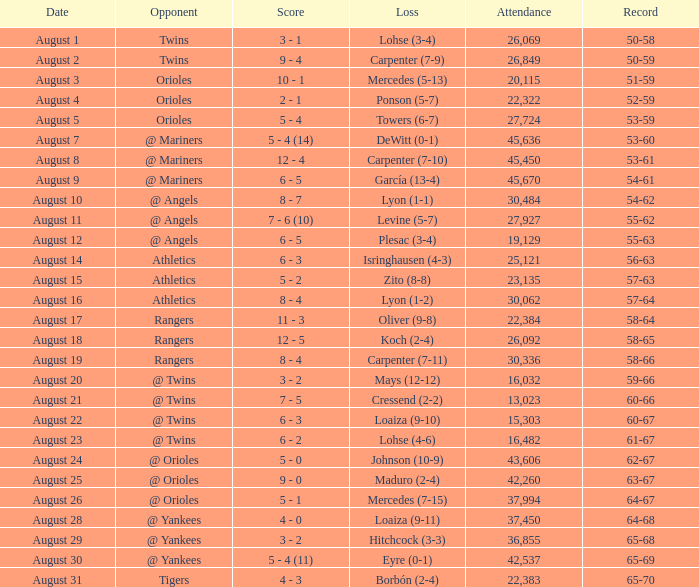What was the score of the game when their record was 62-67 5 - 0. Would you be able to parse every entry in this table? {'header': ['Date', 'Opponent', 'Score', 'Loss', 'Attendance', 'Record'], 'rows': [['August 1', 'Twins', '3 - 1', 'Lohse (3-4)', '26,069', '50-58'], ['August 2', 'Twins', '9 - 4', 'Carpenter (7-9)', '26,849', '50-59'], ['August 3', 'Orioles', '10 - 1', 'Mercedes (5-13)', '20,115', '51-59'], ['August 4', 'Orioles', '2 - 1', 'Ponson (5-7)', '22,322', '52-59'], ['August 5', 'Orioles', '5 - 4', 'Towers (6-7)', '27,724', '53-59'], ['August 7', '@ Mariners', '5 - 4 (14)', 'DeWitt (0-1)', '45,636', '53-60'], ['August 8', '@ Mariners', '12 - 4', 'Carpenter (7-10)', '45,450', '53-61'], ['August 9', '@ Mariners', '6 - 5', 'García (13-4)', '45,670', '54-61'], ['August 10', '@ Angels', '8 - 7', 'Lyon (1-1)', '30,484', '54-62'], ['August 11', '@ Angels', '7 - 6 (10)', 'Levine (5-7)', '27,927', '55-62'], ['August 12', '@ Angels', '6 - 5', 'Plesac (3-4)', '19,129', '55-63'], ['August 14', 'Athletics', '6 - 3', 'Isringhausen (4-3)', '25,121', '56-63'], ['August 15', 'Athletics', '5 - 2', 'Zito (8-8)', '23,135', '57-63'], ['August 16', 'Athletics', '8 - 4', 'Lyon (1-2)', '30,062', '57-64'], ['August 17', 'Rangers', '11 - 3', 'Oliver (9-8)', '22,384', '58-64'], ['August 18', 'Rangers', '12 - 5', 'Koch (2-4)', '26,092', '58-65'], ['August 19', 'Rangers', '8 - 4', 'Carpenter (7-11)', '30,336', '58-66'], ['August 20', '@ Twins', '3 - 2', 'Mays (12-12)', '16,032', '59-66'], ['August 21', '@ Twins', '7 - 5', 'Cressend (2-2)', '13,023', '60-66'], ['August 22', '@ Twins', '6 - 3', 'Loaiza (9-10)', '15,303', '60-67'], ['August 23', '@ Twins', '6 - 2', 'Lohse (4-6)', '16,482', '61-67'], ['August 24', '@ Orioles', '5 - 0', 'Johnson (10-9)', '43,606', '62-67'], ['August 25', '@ Orioles', '9 - 0', 'Maduro (2-4)', '42,260', '63-67'], ['August 26', '@ Orioles', '5 - 1', 'Mercedes (7-15)', '37,994', '64-67'], ['August 28', '@ Yankees', '4 - 0', 'Loaiza (9-11)', '37,450', '64-68'], ['August 29', '@ Yankees', '3 - 2', 'Hitchcock (3-3)', '36,855', '65-68'], ['August 30', '@ Yankees', '5 - 4 (11)', 'Eyre (0-1)', '42,537', '65-69'], ['August 31', 'Tigers', '4 - 3', 'Borbón (2-4)', '22,383', '65-70']]} 